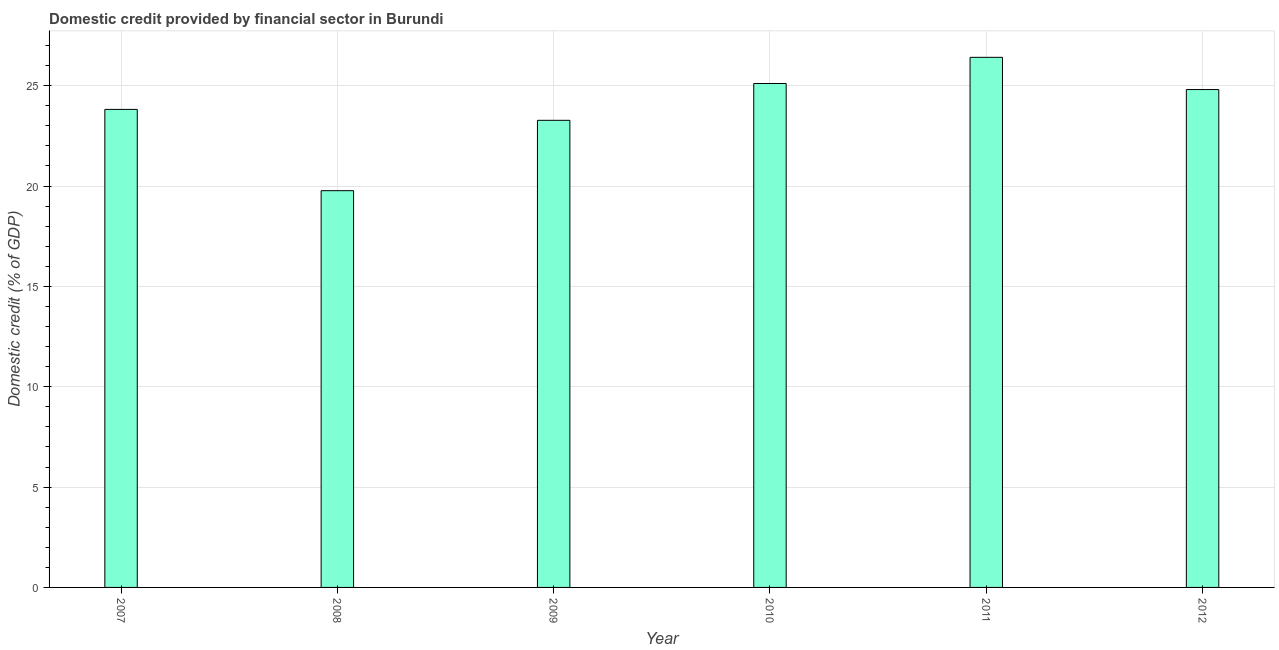What is the title of the graph?
Keep it short and to the point. Domestic credit provided by financial sector in Burundi. What is the label or title of the Y-axis?
Provide a short and direct response. Domestic credit (% of GDP). What is the domestic credit provided by financial sector in 2011?
Provide a short and direct response. 26.41. Across all years, what is the maximum domestic credit provided by financial sector?
Give a very brief answer. 26.41. Across all years, what is the minimum domestic credit provided by financial sector?
Provide a succinct answer. 19.77. In which year was the domestic credit provided by financial sector maximum?
Provide a short and direct response. 2011. In which year was the domestic credit provided by financial sector minimum?
Provide a succinct answer. 2008. What is the sum of the domestic credit provided by financial sector?
Your response must be concise. 143.19. What is the difference between the domestic credit provided by financial sector in 2008 and 2010?
Your answer should be compact. -5.34. What is the average domestic credit provided by financial sector per year?
Keep it short and to the point. 23.86. What is the median domestic credit provided by financial sector?
Your answer should be very brief. 24.31. In how many years, is the domestic credit provided by financial sector greater than 15 %?
Make the answer very short. 6. What is the ratio of the domestic credit provided by financial sector in 2008 to that in 2011?
Offer a terse response. 0.75. What is the difference between the highest and the second highest domestic credit provided by financial sector?
Offer a terse response. 1.3. What is the difference between the highest and the lowest domestic credit provided by financial sector?
Offer a very short reply. 6.64. How many bars are there?
Provide a short and direct response. 6. Are all the bars in the graph horizontal?
Keep it short and to the point. No. What is the difference between two consecutive major ticks on the Y-axis?
Provide a succinct answer. 5. Are the values on the major ticks of Y-axis written in scientific E-notation?
Keep it short and to the point. No. What is the Domestic credit (% of GDP) in 2007?
Provide a succinct answer. 23.82. What is the Domestic credit (% of GDP) of 2008?
Your answer should be compact. 19.77. What is the Domestic credit (% of GDP) of 2009?
Offer a terse response. 23.27. What is the Domestic credit (% of GDP) in 2010?
Your answer should be compact. 25.11. What is the Domestic credit (% of GDP) in 2011?
Offer a terse response. 26.41. What is the Domestic credit (% of GDP) in 2012?
Your response must be concise. 24.81. What is the difference between the Domestic credit (% of GDP) in 2007 and 2008?
Keep it short and to the point. 4.05. What is the difference between the Domestic credit (% of GDP) in 2007 and 2009?
Your answer should be compact. 0.54. What is the difference between the Domestic credit (% of GDP) in 2007 and 2010?
Keep it short and to the point. -1.29. What is the difference between the Domestic credit (% of GDP) in 2007 and 2011?
Provide a short and direct response. -2.59. What is the difference between the Domestic credit (% of GDP) in 2007 and 2012?
Offer a terse response. -0.99. What is the difference between the Domestic credit (% of GDP) in 2008 and 2009?
Provide a short and direct response. -3.51. What is the difference between the Domestic credit (% of GDP) in 2008 and 2010?
Make the answer very short. -5.34. What is the difference between the Domestic credit (% of GDP) in 2008 and 2011?
Your answer should be compact. -6.64. What is the difference between the Domestic credit (% of GDP) in 2008 and 2012?
Your answer should be very brief. -5.04. What is the difference between the Domestic credit (% of GDP) in 2009 and 2010?
Provide a short and direct response. -1.84. What is the difference between the Domestic credit (% of GDP) in 2009 and 2011?
Your answer should be compact. -3.14. What is the difference between the Domestic credit (% of GDP) in 2009 and 2012?
Your answer should be compact. -1.53. What is the difference between the Domestic credit (% of GDP) in 2010 and 2011?
Provide a short and direct response. -1.3. What is the difference between the Domestic credit (% of GDP) in 2010 and 2012?
Offer a very short reply. 0.3. What is the difference between the Domestic credit (% of GDP) in 2011 and 2012?
Your response must be concise. 1.61. What is the ratio of the Domestic credit (% of GDP) in 2007 to that in 2008?
Keep it short and to the point. 1.21. What is the ratio of the Domestic credit (% of GDP) in 2007 to that in 2010?
Provide a short and direct response. 0.95. What is the ratio of the Domestic credit (% of GDP) in 2007 to that in 2011?
Your response must be concise. 0.9. What is the ratio of the Domestic credit (% of GDP) in 2007 to that in 2012?
Ensure brevity in your answer.  0.96. What is the ratio of the Domestic credit (% of GDP) in 2008 to that in 2009?
Give a very brief answer. 0.85. What is the ratio of the Domestic credit (% of GDP) in 2008 to that in 2010?
Your response must be concise. 0.79. What is the ratio of the Domestic credit (% of GDP) in 2008 to that in 2011?
Keep it short and to the point. 0.75. What is the ratio of the Domestic credit (% of GDP) in 2008 to that in 2012?
Provide a succinct answer. 0.8. What is the ratio of the Domestic credit (% of GDP) in 2009 to that in 2010?
Provide a succinct answer. 0.93. What is the ratio of the Domestic credit (% of GDP) in 2009 to that in 2011?
Offer a terse response. 0.88. What is the ratio of the Domestic credit (% of GDP) in 2009 to that in 2012?
Provide a short and direct response. 0.94. What is the ratio of the Domestic credit (% of GDP) in 2010 to that in 2011?
Your answer should be compact. 0.95. What is the ratio of the Domestic credit (% of GDP) in 2010 to that in 2012?
Your answer should be very brief. 1.01. What is the ratio of the Domestic credit (% of GDP) in 2011 to that in 2012?
Provide a succinct answer. 1.06. 